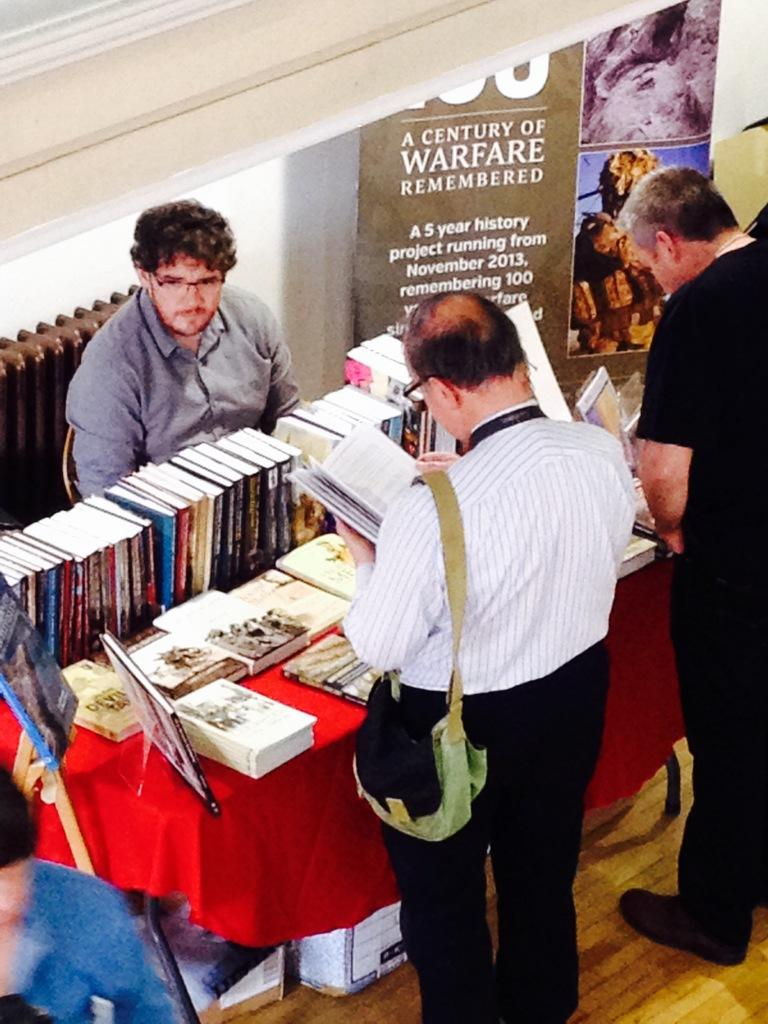<image>
Provide a brief description of the given image. A man sitting at a table of books next to a sign reading "A Century of Warfare Remembered" 